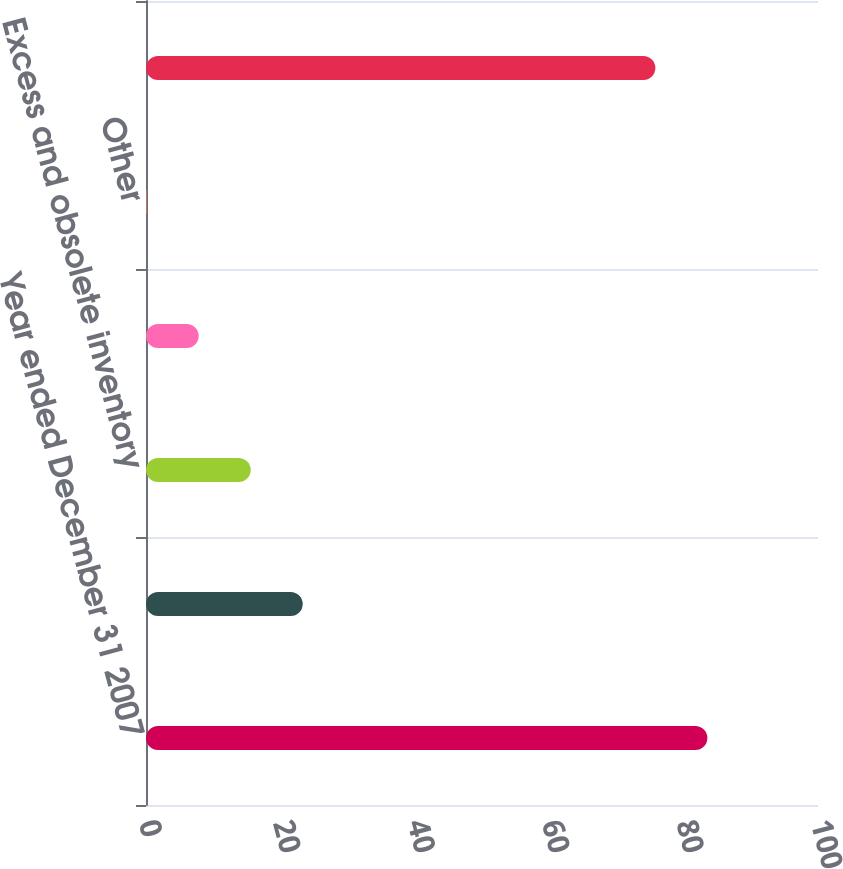Convert chart to OTSL. <chart><loc_0><loc_0><loc_500><loc_500><bar_chart><fcel>Year ended December 31 2007<fcel>Foreign currency exchange<fcel>Excess and obsolete inventory<fcel>Inventory step-up<fcel>Other<fcel>Year ended December 31 2008<nl><fcel>83.54<fcel>23.32<fcel>15.58<fcel>7.84<fcel>0.1<fcel>75.8<nl></chart> 